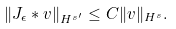Convert formula to latex. <formula><loc_0><loc_0><loc_500><loc_500>\| J _ { \epsilon } \ast v \| _ { H ^ { s ^ { \prime } } } \leq C \| v \| _ { H ^ { s } } .</formula> 